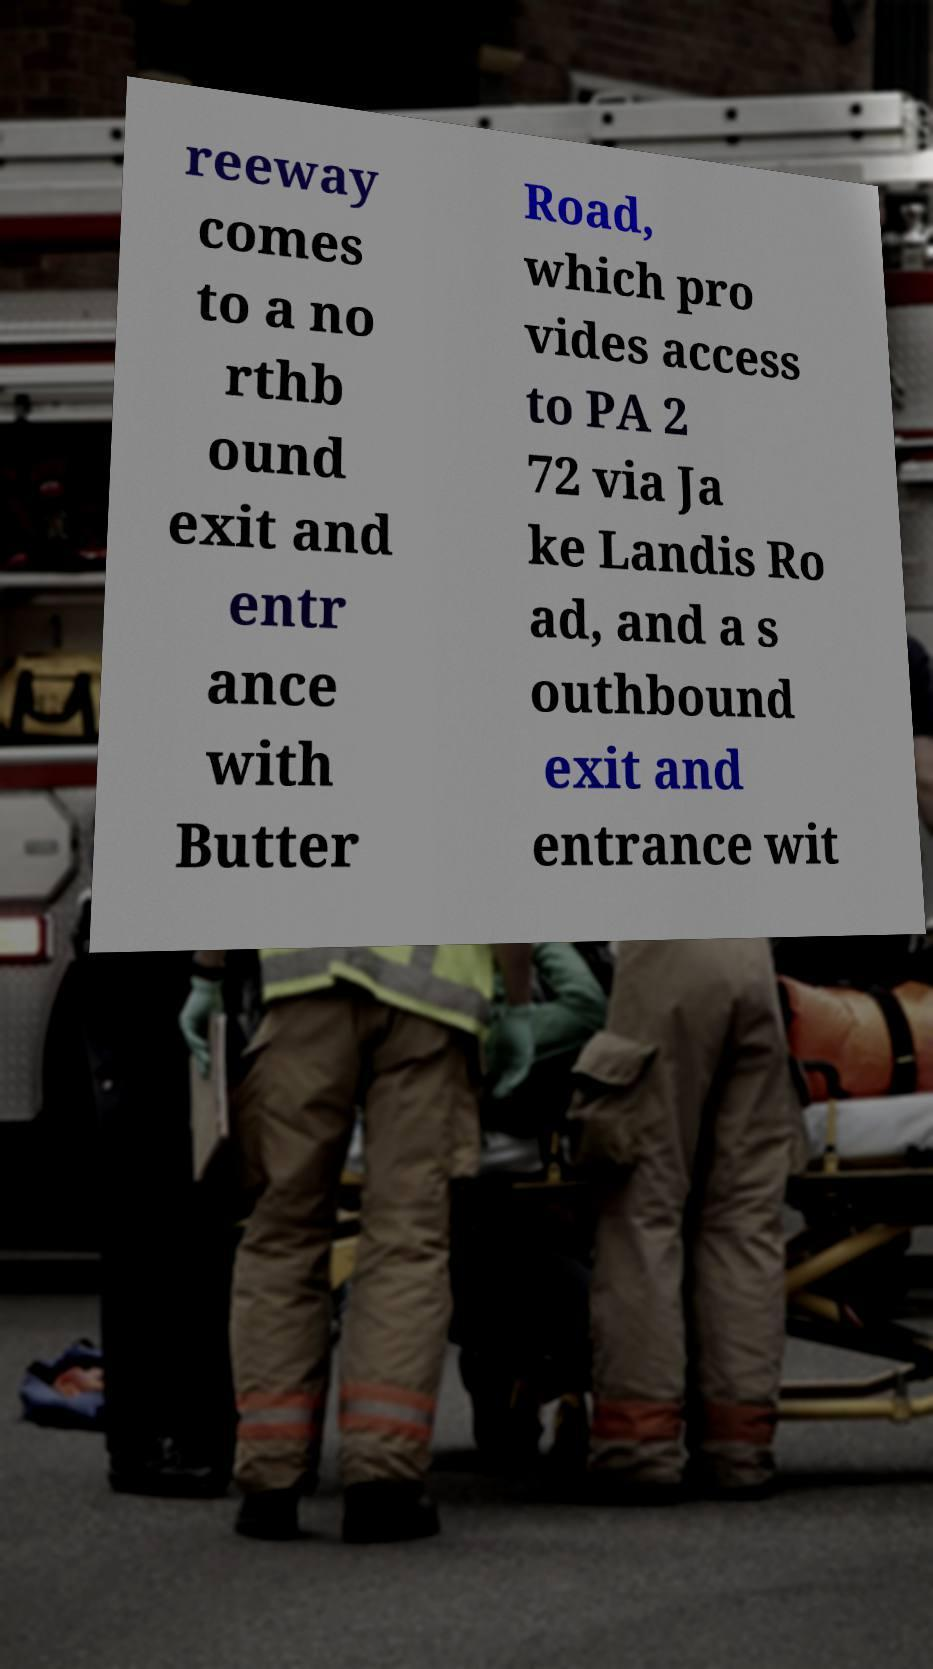Please identify and transcribe the text found in this image. reeway comes to a no rthb ound exit and entr ance with Butter Road, which pro vides access to PA 2 72 via Ja ke Landis Ro ad, and a s outhbound exit and entrance wit 